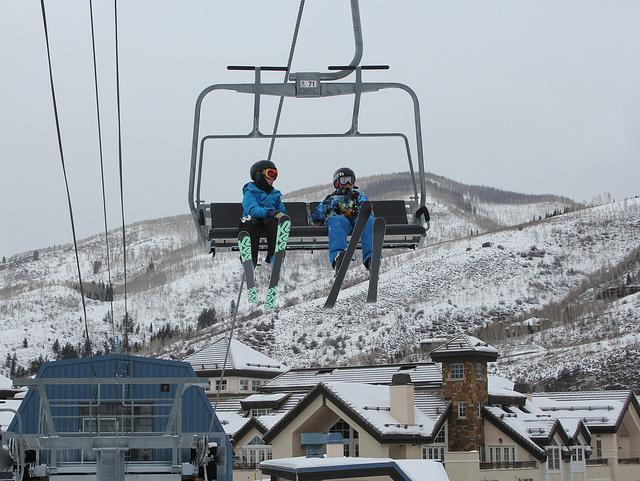Which comparative elevation do the seated people wish for?

Choices:
A) lower
B) none
C) same
D) higher higher 